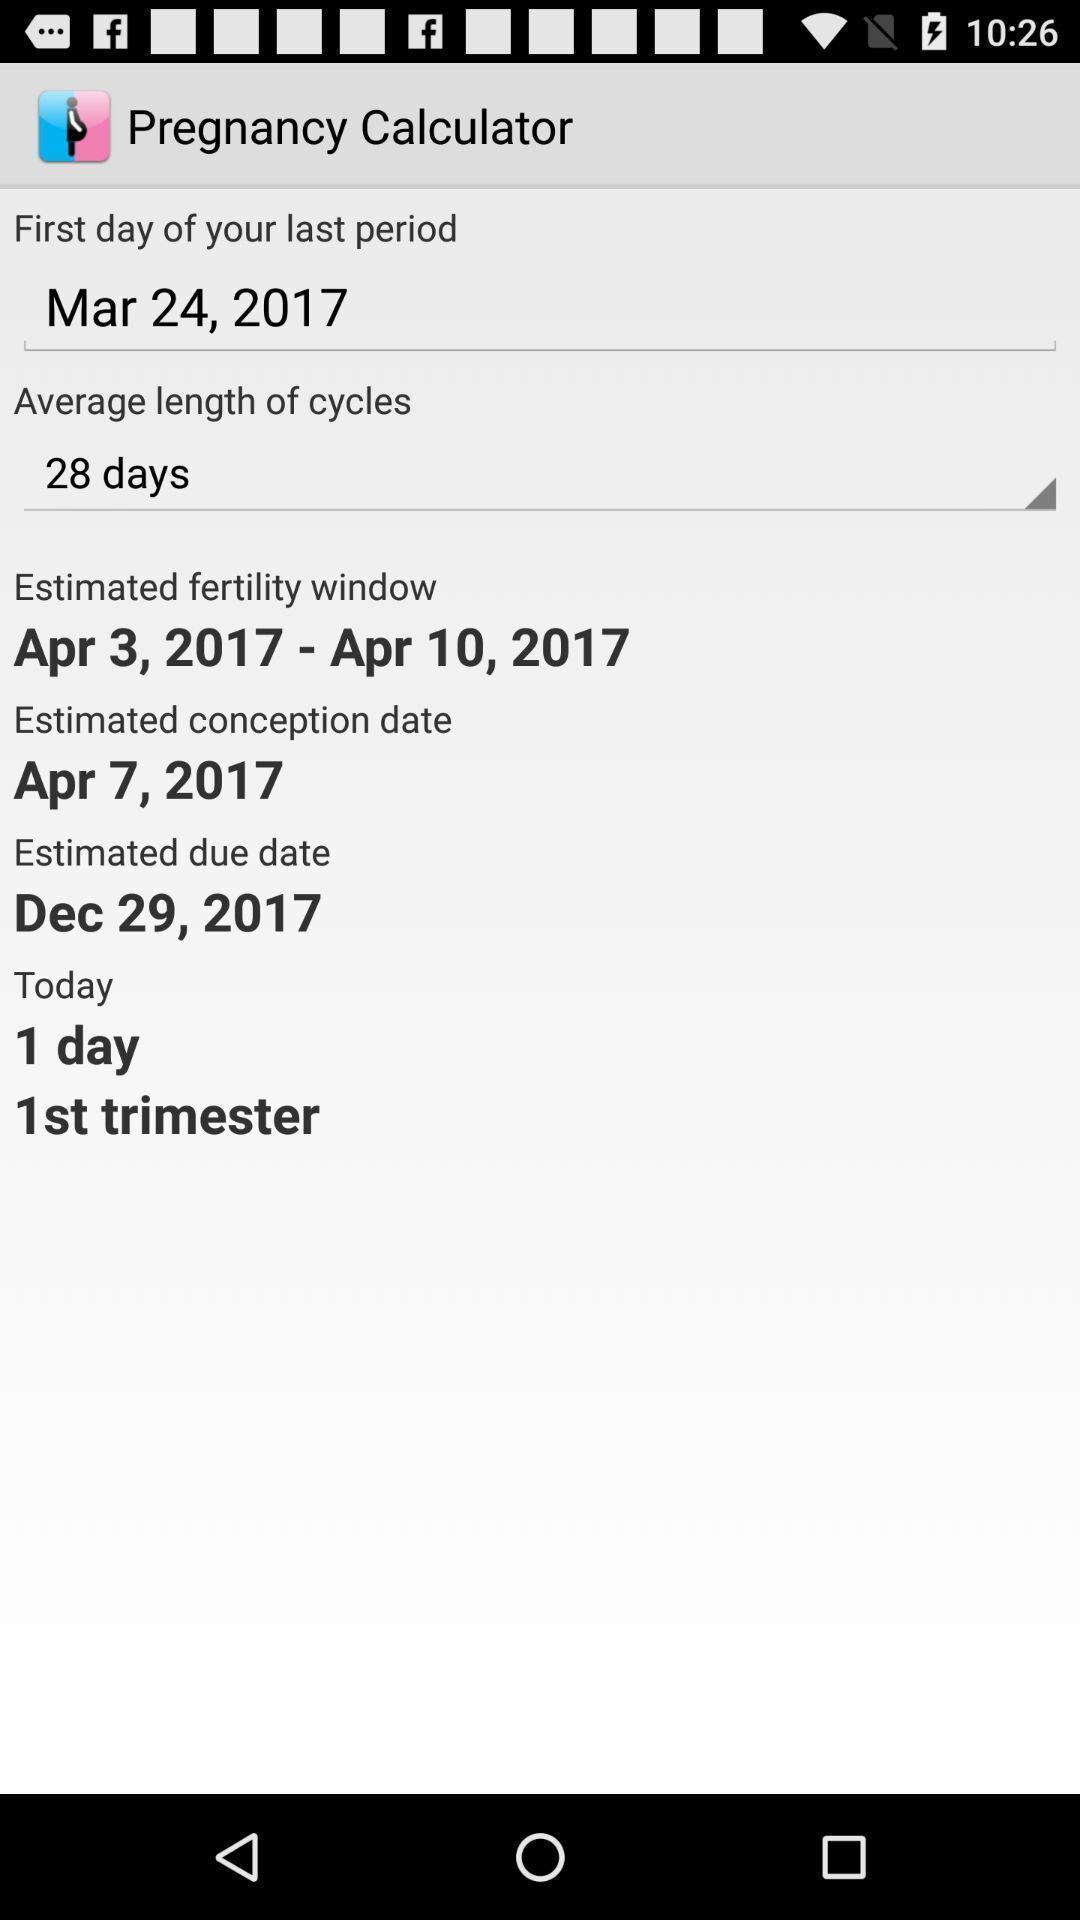What details can you identify in this image? Pregnancy calculator page showing in application. 